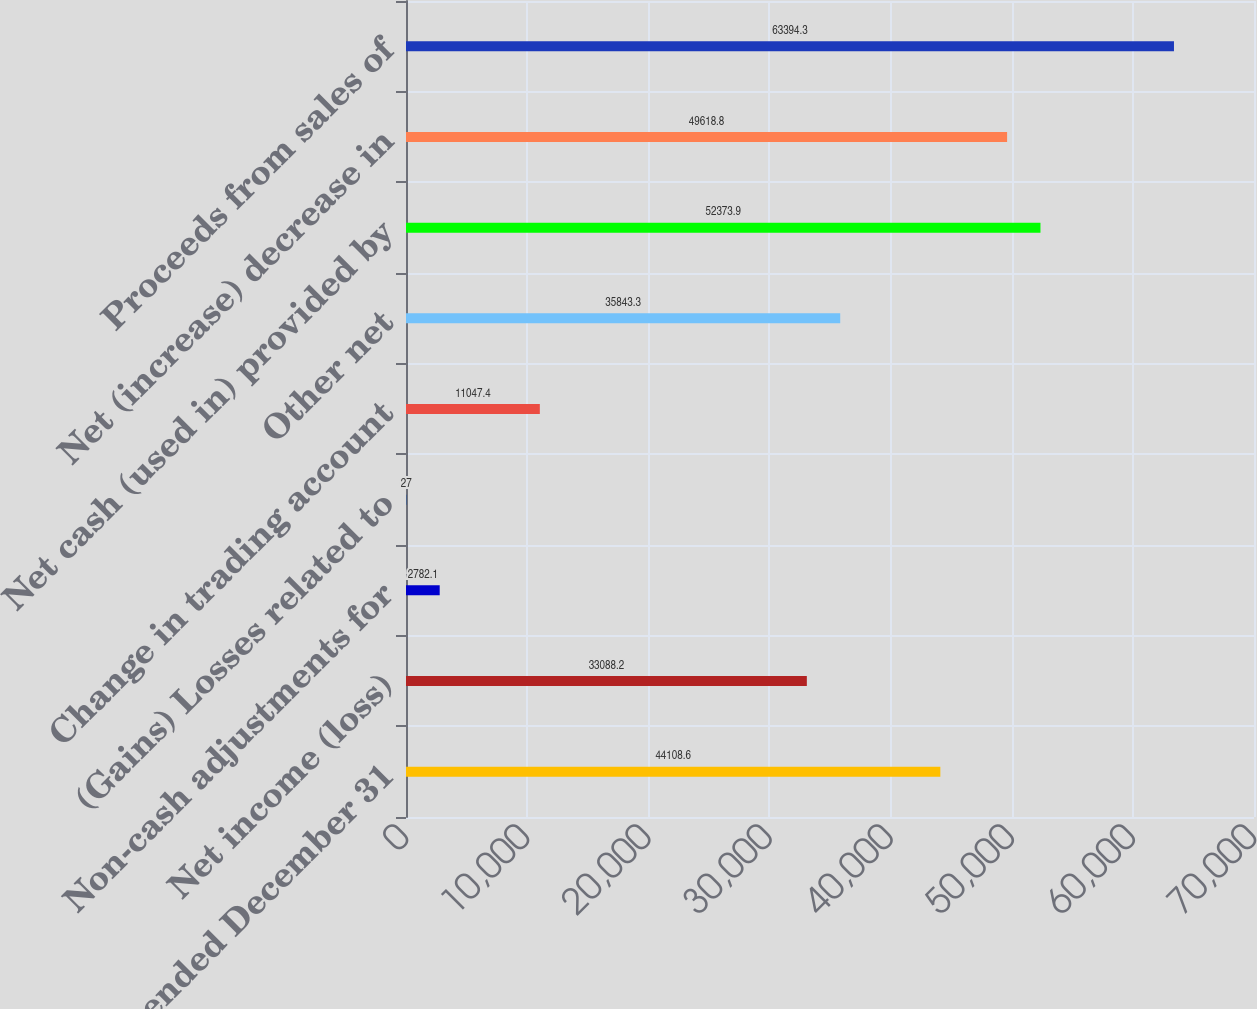<chart> <loc_0><loc_0><loc_500><loc_500><bar_chart><fcel>Years ended December 31<fcel>Net income (loss)<fcel>Non-cash adjustments for<fcel>(Gains) Losses related to<fcel>Change in trading account<fcel>Other net<fcel>Net cash (used in) provided by<fcel>Net (increase) decrease in<fcel>Proceeds from sales of<nl><fcel>44108.6<fcel>33088.2<fcel>2782.1<fcel>27<fcel>11047.4<fcel>35843.3<fcel>52373.9<fcel>49618.8<fcel>63394.3<nl></chart> 